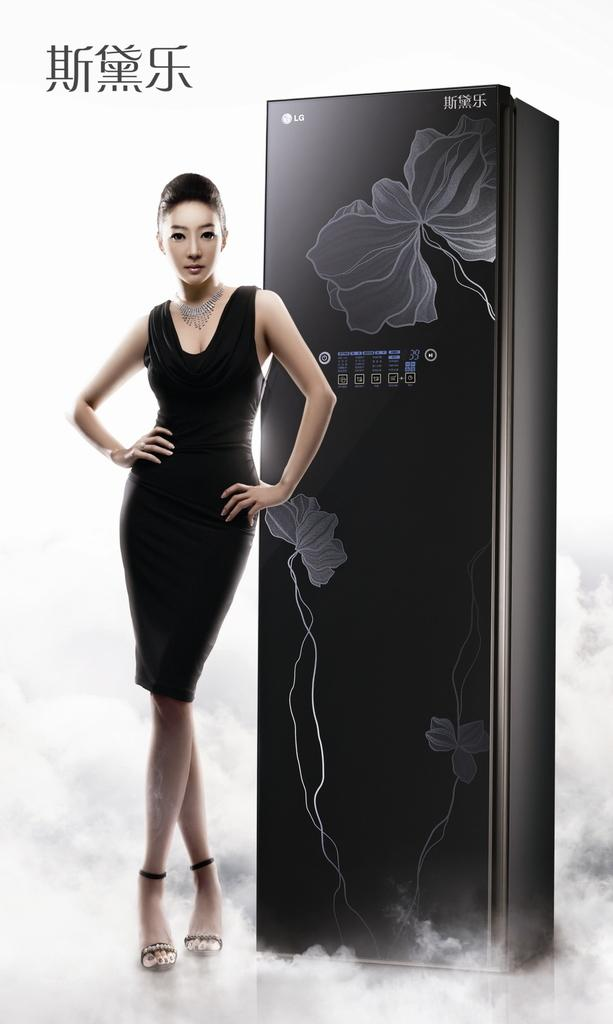Who is the main subject in the image? There is a woman in the image. What is the woman wearing? The woman is wearing a black dress. What is the woman doing in the image? The woman is standing. What other object can be seen in the image? There is a black color refrigerator in the image. What type of flame can be seen coming from the woman's head in the image? There is no flame present in the image; the woman is wearing a black dress and standing near a refrigerator. 